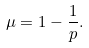Convert formula to latex. <formula><loc_0><loc_0><loc_500><loc_500>\mu = 1 - \frac { 1 } { p } .</formula> 